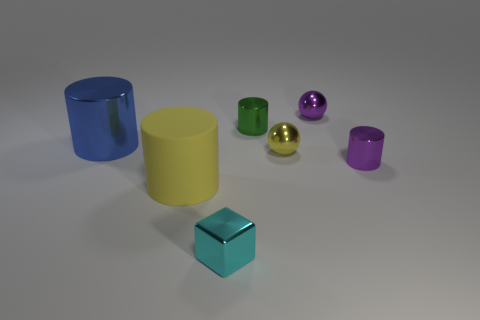The tiny cylinder to the right of the tiny yellow shiny object is what color?
Offer a very short reply. Purple. Is there anything else that is the same color as the metallic cube?
Ensure brevity in your answer.  No. Does the yellow rubber cylinder have the same size as the cube?
Keep it short and to the point. No. There is a cylinder that is on the right side of the yellow matte cylinder and in front of the tiny green metallic object; what size is it?
Your response must be concise. Small. What number of green things are the same material as the green cylinder?
Provide a succinct answer. 0. The other small thing that is the same color as the rubber object is what shape?
Keep it short and to the point. Sphere. The big matte thing has what color?
Make the answer very short. Yellow. There is a purple metal object in front of the tiny purple ball; does it have the same shape as the green object?
Make the answer very short. Yes. How many objects are small purple things behind the green shiny thing or green rubber things?
Offer a very short reply. 1. Are there any large metal objects that have the same shape as the small yellow metal object?
Keep it short and to the point. No. 